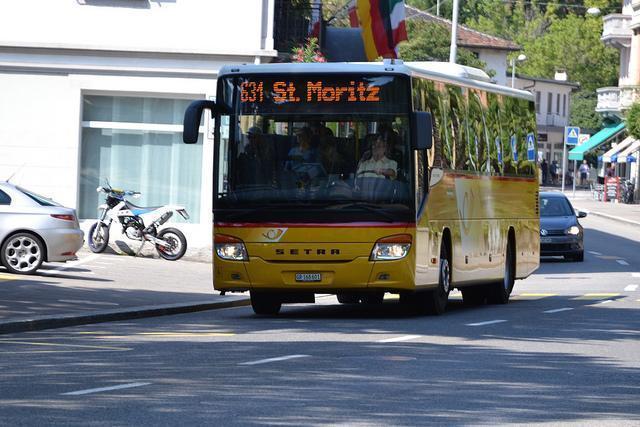What is the speed limit of school bus?
Make your selection and explain in format: 'Answer: answer
Rationale: rationale.'
Options: 60mph, 75mph, 70mph, 50mph. Answer: 50mph.
Rationale: The question is not related to the image but is internet searchable. 